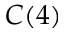<formula> <loc_0><loc_0><loc_500><loc_500>C ( 4 )</formula> 